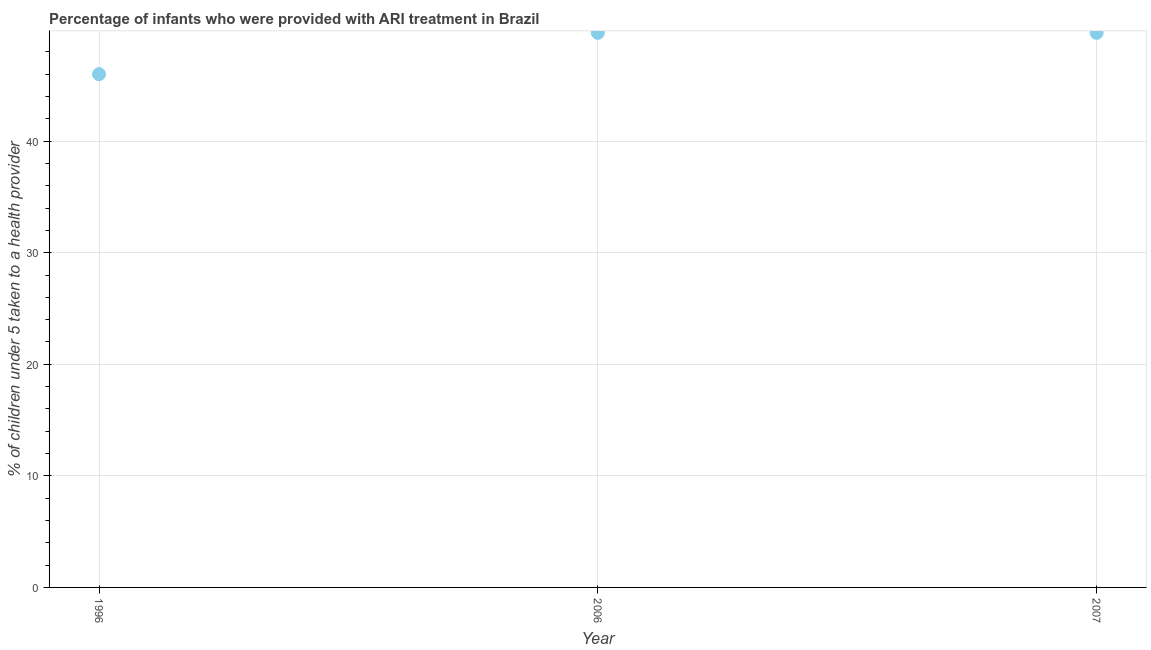What is the percentage of children who were provided with ari treatment in 2006?
Offer a terse response. 49.7. Across all years, what is the maximum percentage of children who were provided with ari treatment?
Offer a very short reply. 49.7. What is the sum of the percentage of children who were provided with ari treatment?
Provide a succinct answer. 145.4. What is the difference between the percentage of children who were provided with ari treatment in 1996 and 2006?
Your answer should be very brief. -3.7. What is the average percentage of children who were provided with ari treatment per year?
Your answer should be compact. 48.47. What is the median percentage of children who were provided with ari treatment?
Keep it short and to the point. 49.7. In how many years, is the percentage of children who were provided with ari treatment greater than 24 %?
Your answer should be very brief. 3. Do a majority of the years between 2007 and 1996 (inclusive) have percentage of children who were provided with ari treatment greater than 2 %?
Provide a succinct answer. No. What is the ratio of the percentage of children who were provided with ari treatment in 1996 to that in 2007?
Keep it short and to the point. 0.93. Is the percentage of children who were provided with ari treatment in 2006 less than that in 2007?
Provide a short and direct response. No. What is the difference between the highest and the second highest percentage of children who were provided with ari treatment?
Provide a short and direct response. 0. Is the sum of the percentage of children who were provided with ari treatment in 1996 and 2007 greater than the maximum percentage of children who were provided with ari treatment across all years?
Your answer should be very brief. Yes. What is the difference between the highest and the lowest percentage of children who were provided with ari treatment?
Your answer should be very brief. 3.7. How many dotlines are there?
Provide a short and direct response. 1. How many years are there in the graph?
Keep it short and to the point. 3. What is the difference between two consecutive major ticks on the Y-axis?
Ensure brevity in your answer.  10. Are the values on the major ticks of Y-axis written in scientific E-notation?
Keep it short and to the point. No. Does the graph contain any zero values?
Offer a very short reply. No. What is the title of the graph?
Provide a short and direct response. Percentage of infants who were provided with ARI treatment in Brazil. What is the label or title of the X-axis?
Offer a very short reply. Year. What is the label or title of the Y-axis?
Provide a succinct answer. % of children under 5 taken to a health provider. What is the % of children under 5 taken to a health provider in 1996?
Offer a very short reply. 46. What is the % of children under 5 taken to a health provider in 2006?
Provide a short and direct response. 49.7. What is the % of children under 5 taken to a health provider in 2007?
Provide a succinct answer. 49.7. What is the difference between the % of children under 5 taken to a health provider in 1996 and 2006?
Provide a short and direct response. -3.7. What is the difference between the % of children under 5 taken to a health provider in 2006 and 2007?
Provide a short and direct response. 0. What is the ratio of the % of children under 5 taken to a health provider in 1996 to that in 2006?
Your response must be concise. 0.93. What is the ratio of the % of children under 5 taken to a health provider in 1996 to that in 2007?
Your response must be concise. 0.93. 